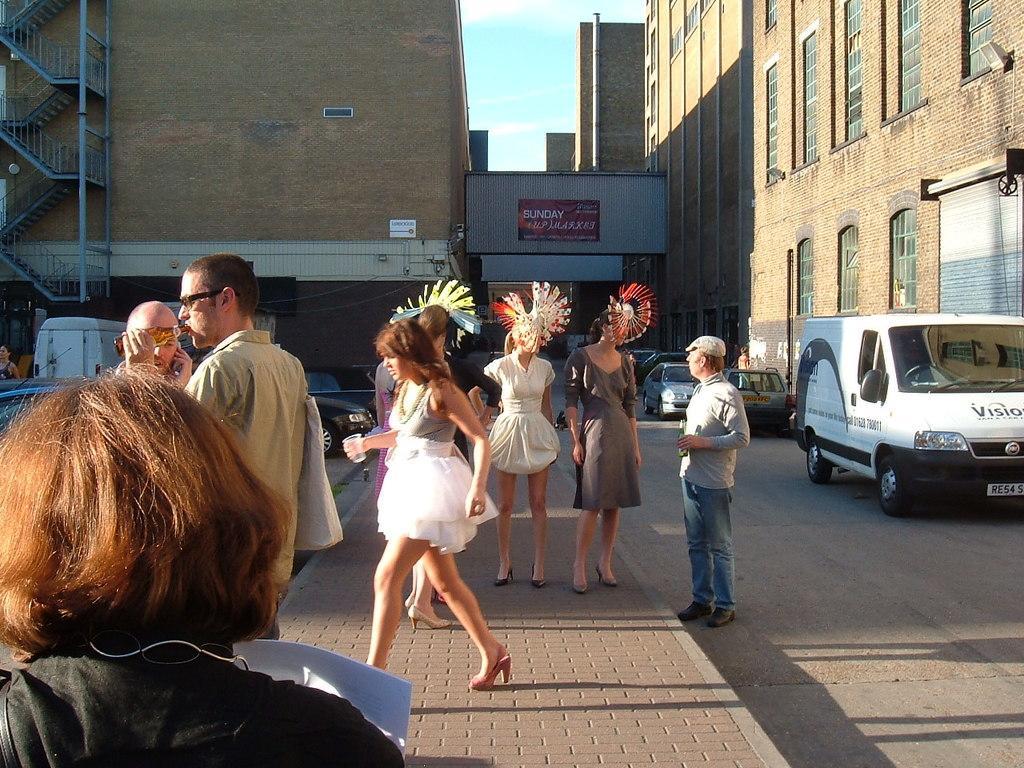Please provide a concise description of this image. In the center of the image there are people on the road. In the background of the image there are buildings. There are vehicles on the road. 